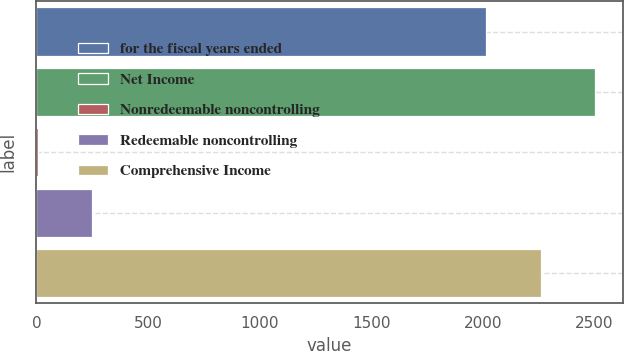<chart> <loc_0><loc_0><loc_500><loc_500><bar_chart><fcel>for the fiscal years ended<fcel>Net Income<fcel>Nonredeemable noncontrolling<fcel>Redeemable noncontrolling<fcel>Comprehensive Income<nl><fcel>2014<fcel>2500.99<fcel>6.8<fcel>247.29<fcel>2260.5<nl></chart> 